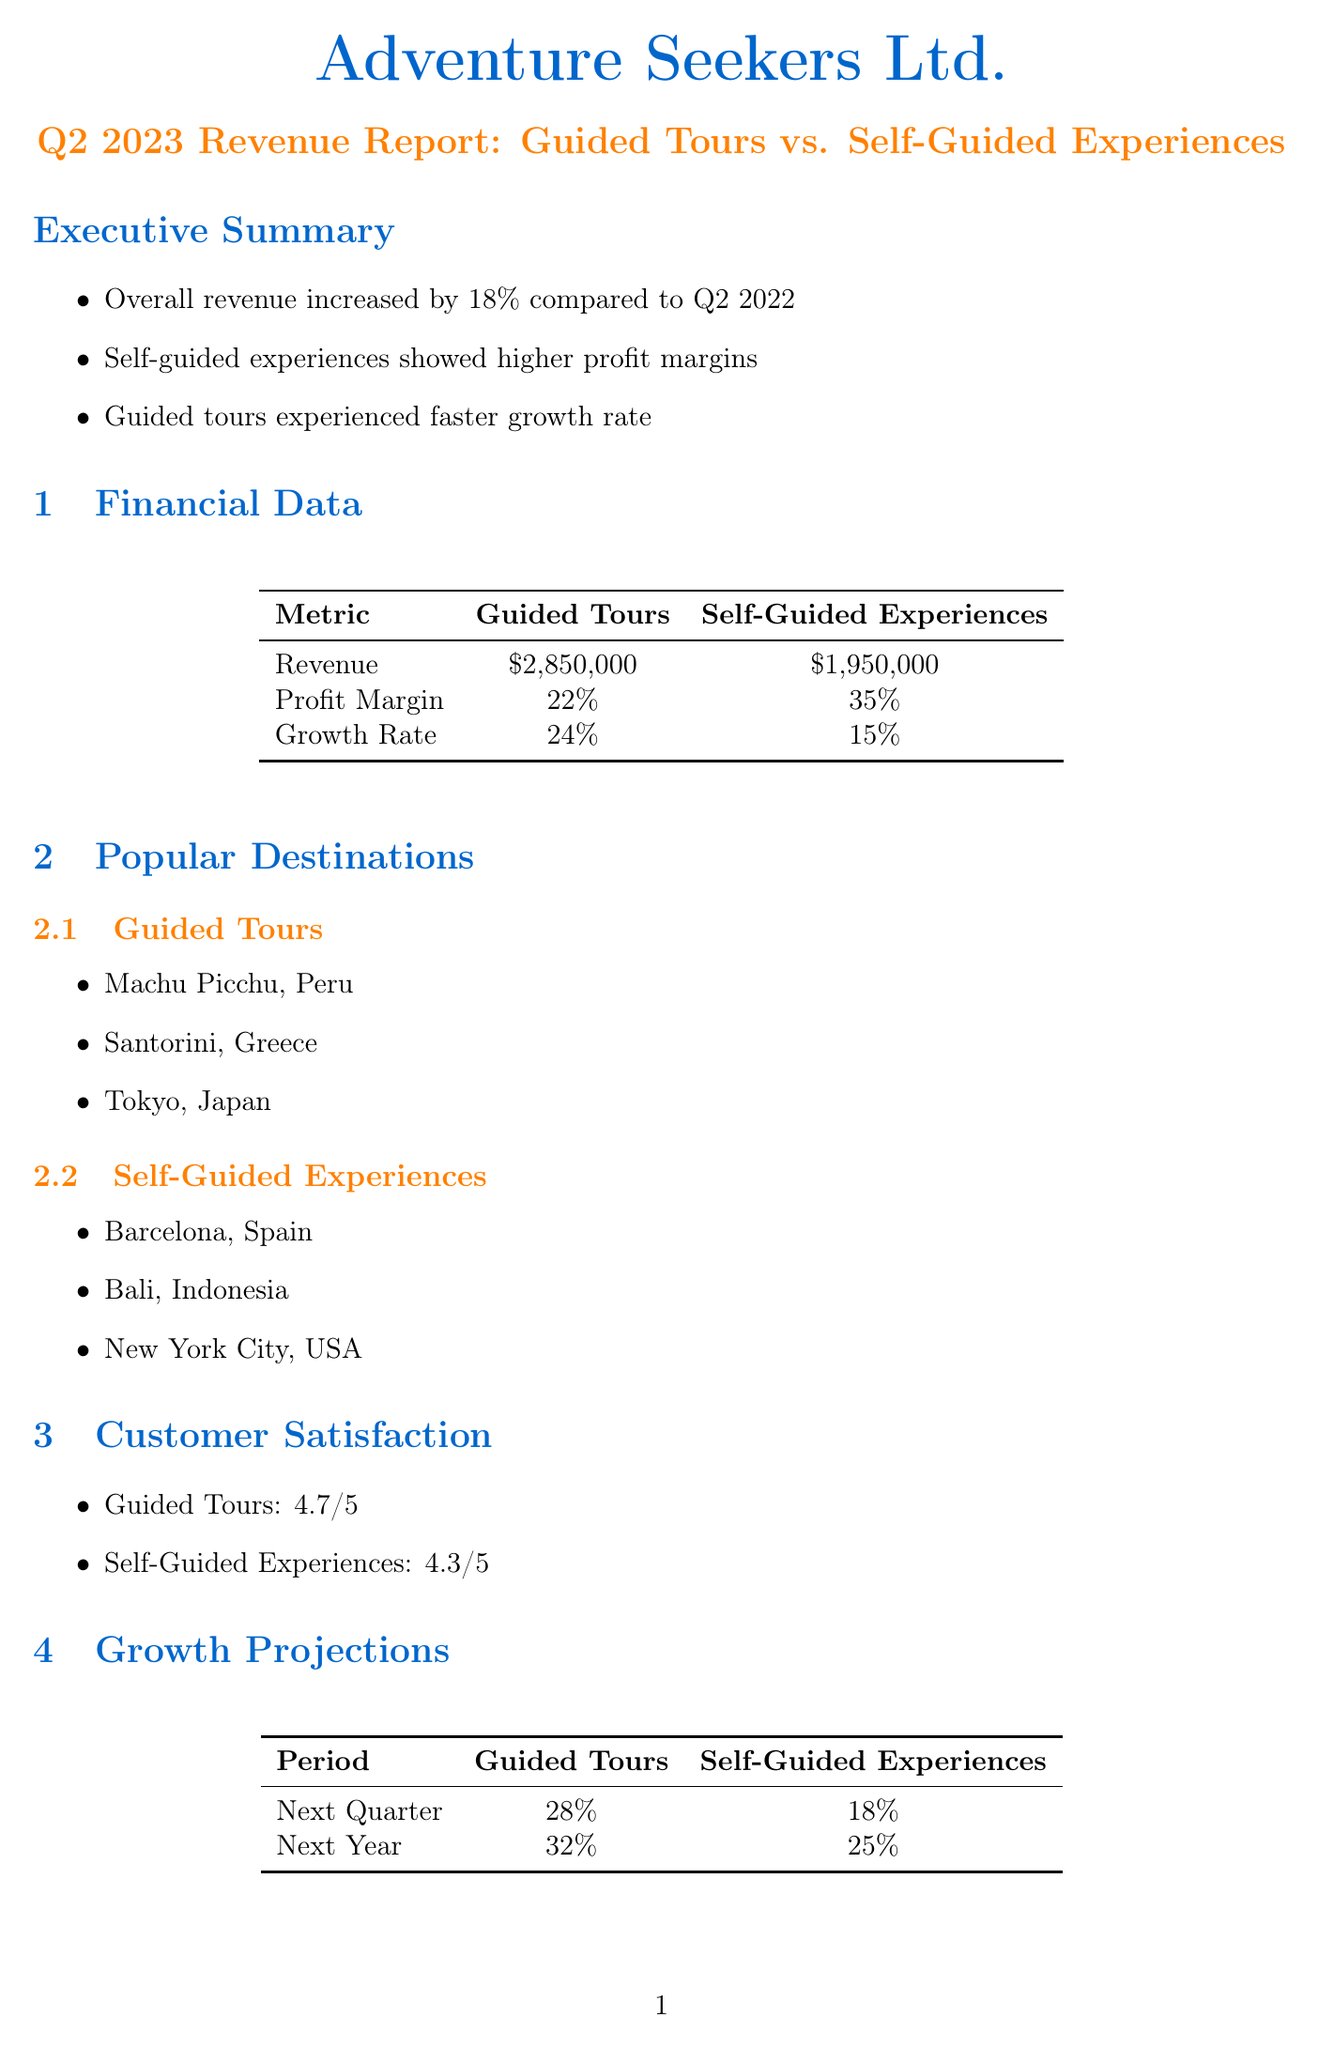What was the overall revenue increase compared to Q2 2022? The document states that the overall revenue increased by 18% compared to Q2 2022.
Answer: 18% What is the profit margin for self-guided experiences? The profit margin for self-guided experiences is specifically mentioned in the financial data section.
Answer: 35% Which category experienced a faster growth rate? The document compares the growth rates of guided tours and self-guided experiences, indicating which one is faster.
Answer: Guided tours What is the customer satisfaction rating for guided tours? The customer satisfaction rating is explicitly mentioned in the customer satisfaction section.
Answer: 4.7/5 What is the projected growth rate for guided tours in the next year? The growth projections provide specific rates for future growth for guided tours.
Answer: 32% Which destination is popular for self-guided experiences? The document lists popular destinations for both categories; one should name a location from the self-guided experiences section.
Answer: Barcelona, Spain What are two future strategies mentioned for self-guided experiences? The future strategies section outlines specific initiatives for self-guided experiences that can be cited directly.
Answer: Expand virtual reality city tours, develop AI-powered personalized itineraries What is one sustainability initiative for guided tours? The sustainability initiatives section lists specific programs related to guided tours, where one could identify a single initiative.
Answer: Carbon offset programs Which competitor is listed in the market analysis section? The document outlines competitors, and one can directly identify a specific competitor mentioned.
Answer: Intrepid Travel 